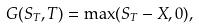<formula> <loc_0><loc_0><loc_500><loc_500>G ( S _ { T } , T ) = \max ( S _ { T } - X , 0 ) ,</formula> 